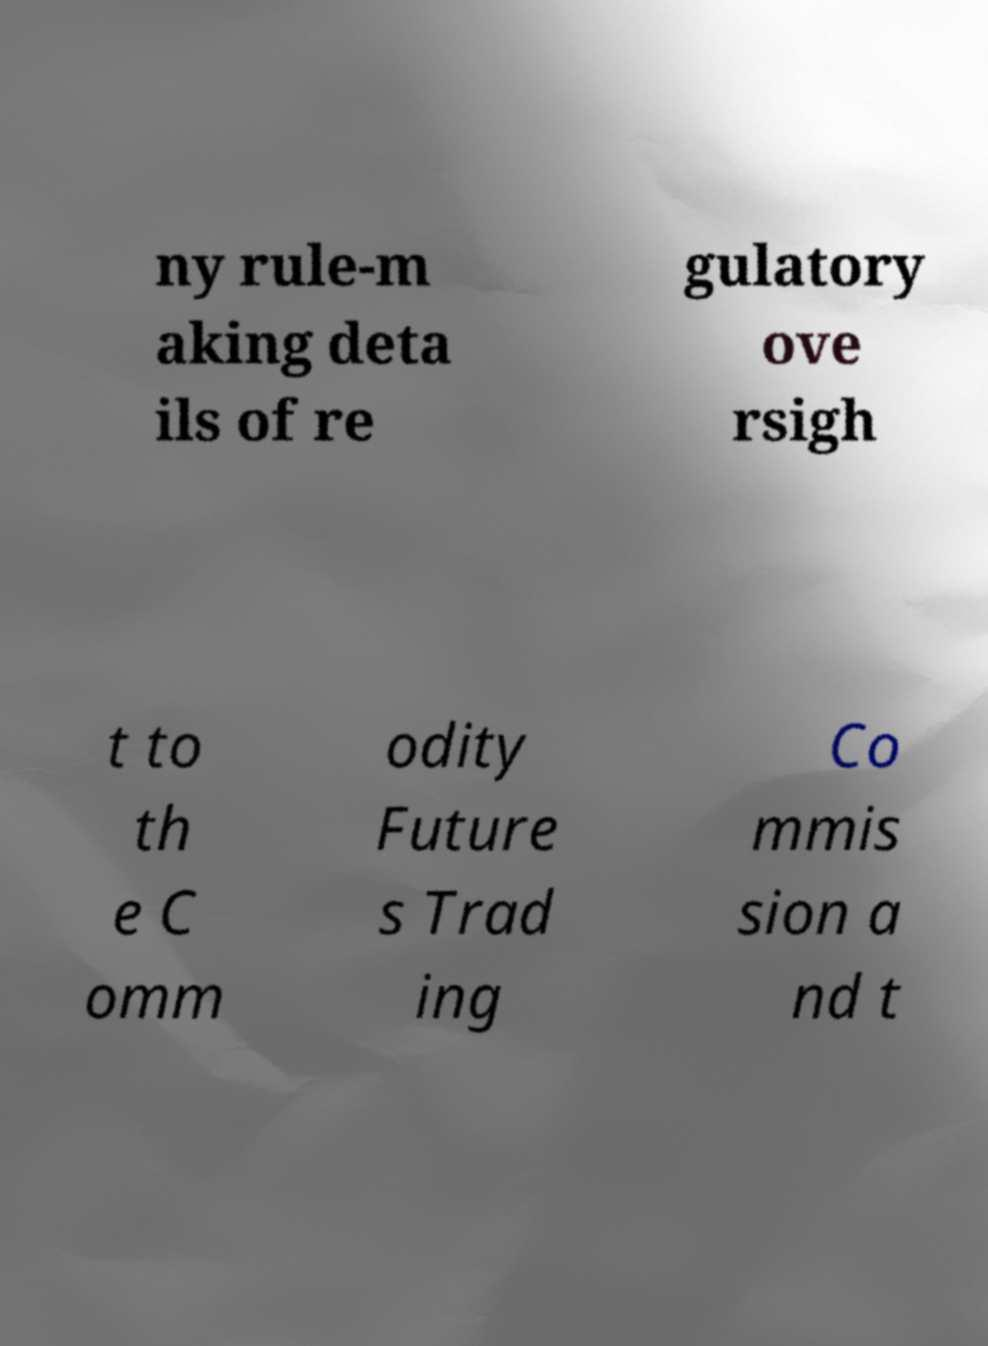For documentation purposes, I need the text within this image transcribed. Could you provide that? ny rule-m aking deta ils of re gulatory ove rsigh t to th e C omm odity Future s Trad ing Co mmis sion a nd t 